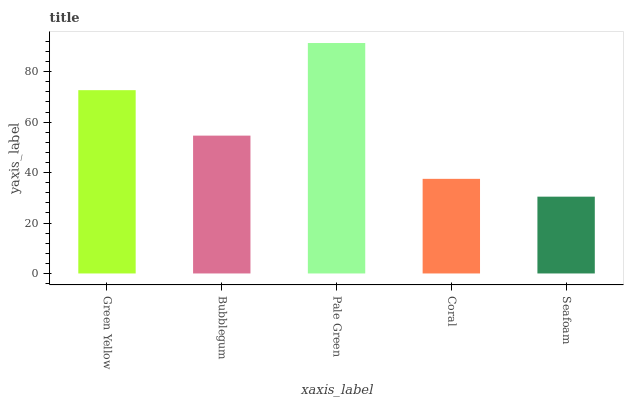Is Seafoam the minimum?
Answer yes or no. Yes. Is Pale Green the maximum?
Answer yes or no. Yes. Is Bubblegum the minimum?
Answer yes or no. No. Is Bubblegum the maximum?
Answer yes or no. No. Is Green Yellow greater than Bubblegum?
Answer yes or no. Yes. Is Bubblegum less than Green Yellow?
Answer yes or no. Yes. Is Bubblegum greater than Green Yellow?
Answer yes or no. No. Is Green Yellow less than Bubblegum?
Answer yes or no. No. Is Bubblegum the high median?
Answer yes or no. Yes. Is Bubblegum the low median?
Answer yes or no. Yes. Is Coral the high median?
Answer yes or no. No. Is Coral the low median?
Answer yes or no. No. 